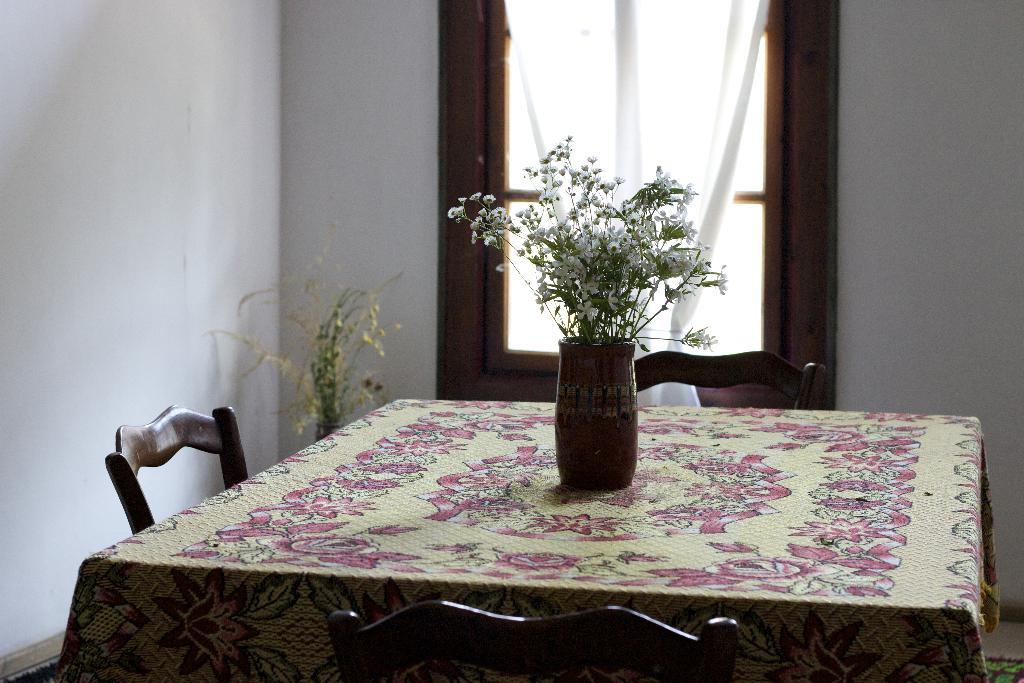What can be seen in the background of the image? There is a wall and a window in the background of the image. What type of window treatment is present in the image? There are curtains associated with the window in the image. What is on the table in the image? There is a cloth on the table and a flower vase on the table. What type of seating is near the table? There are chairs near the table. What type of vegetation is present in the image? There is a plant in the image. What type of oil can be seen dripping from the plant in the image? There is no oil dripping from the plant in the image; it is a plant without any visible oil. 